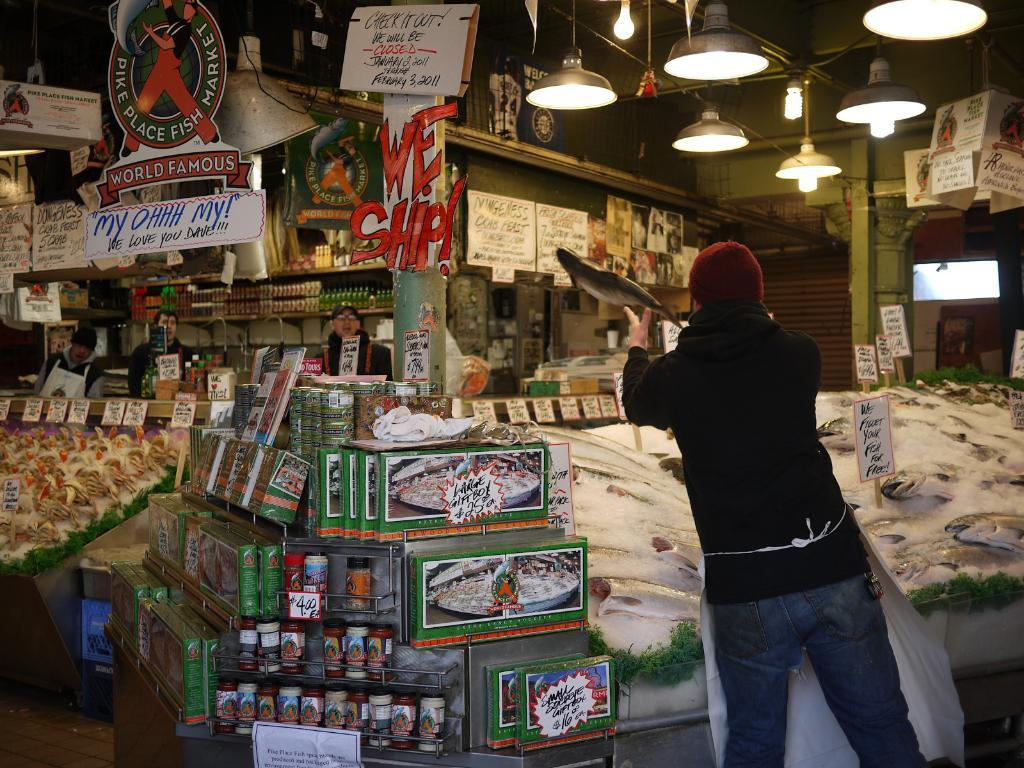<image>
Provide a brief description of the given image. A man throws a fish near a we ship sign. 